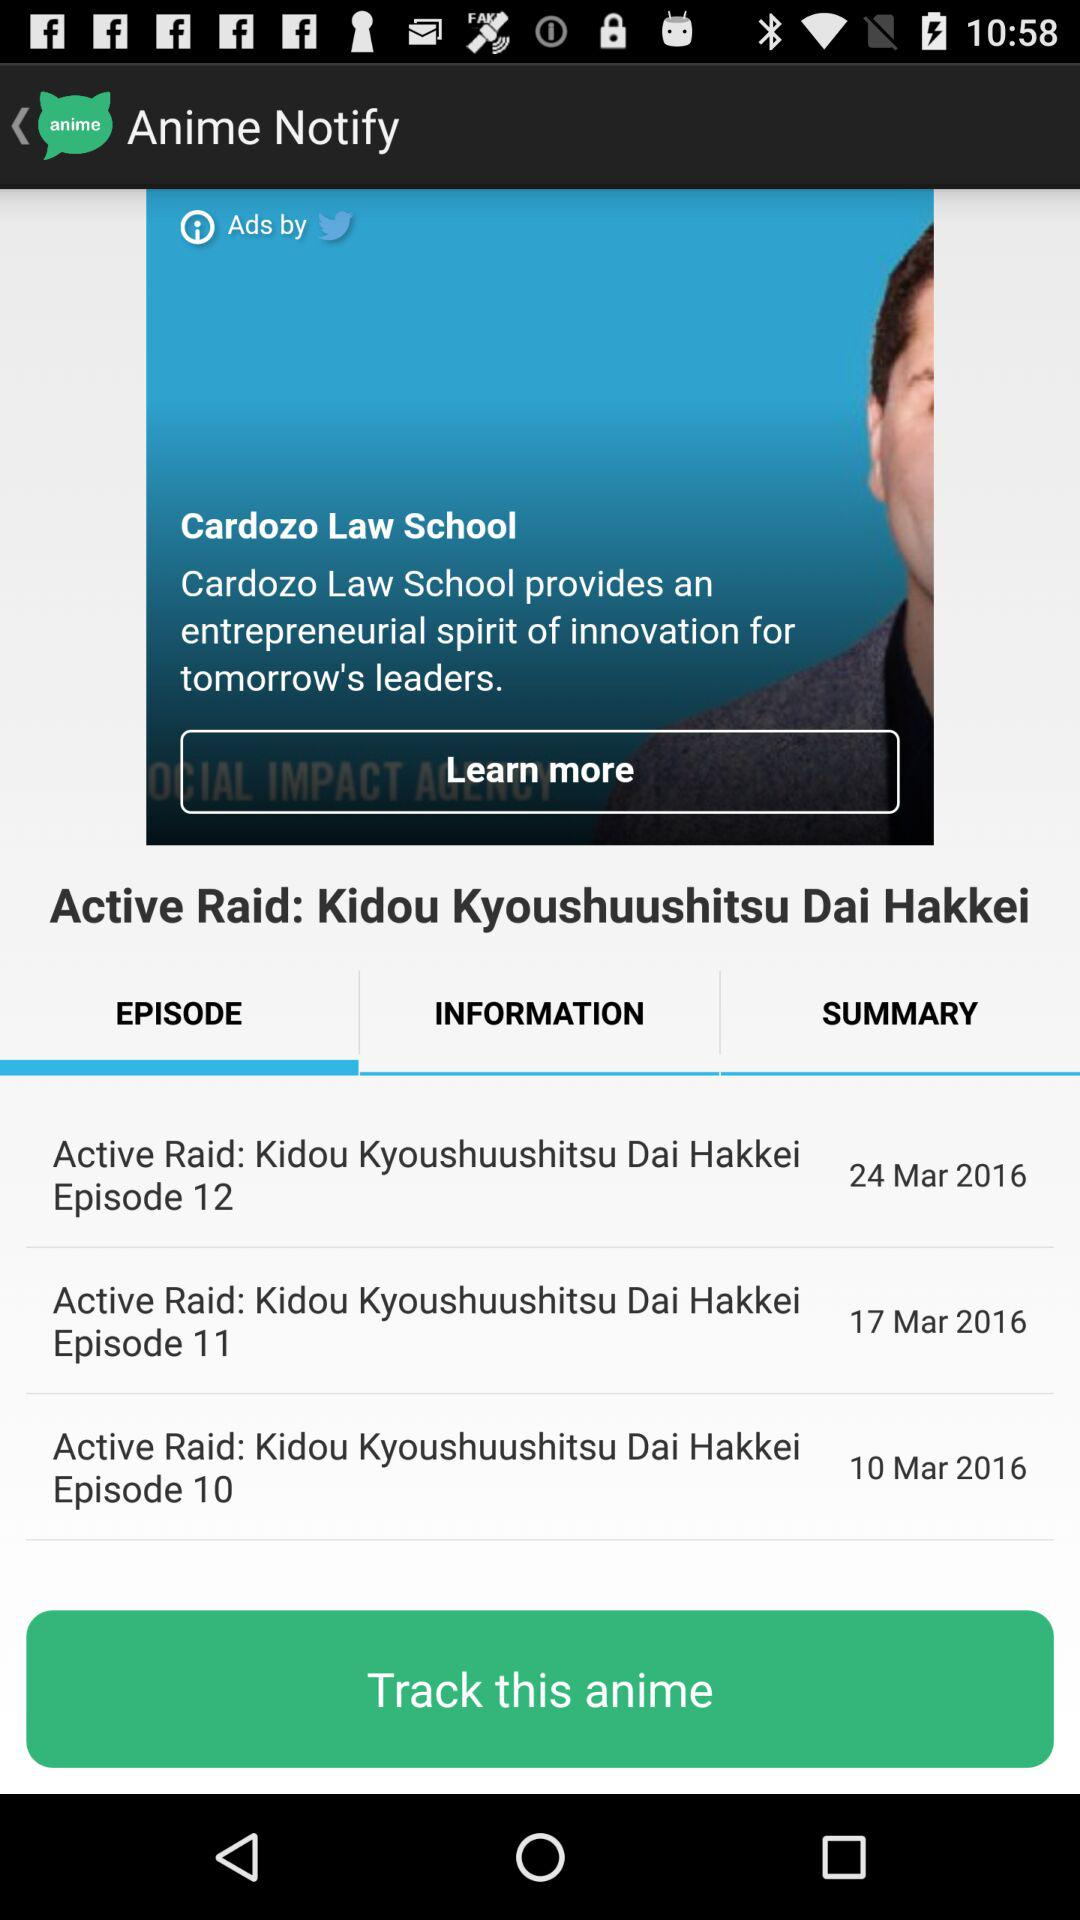Which tab is currently selected? The selected tab is "EPISODE". 